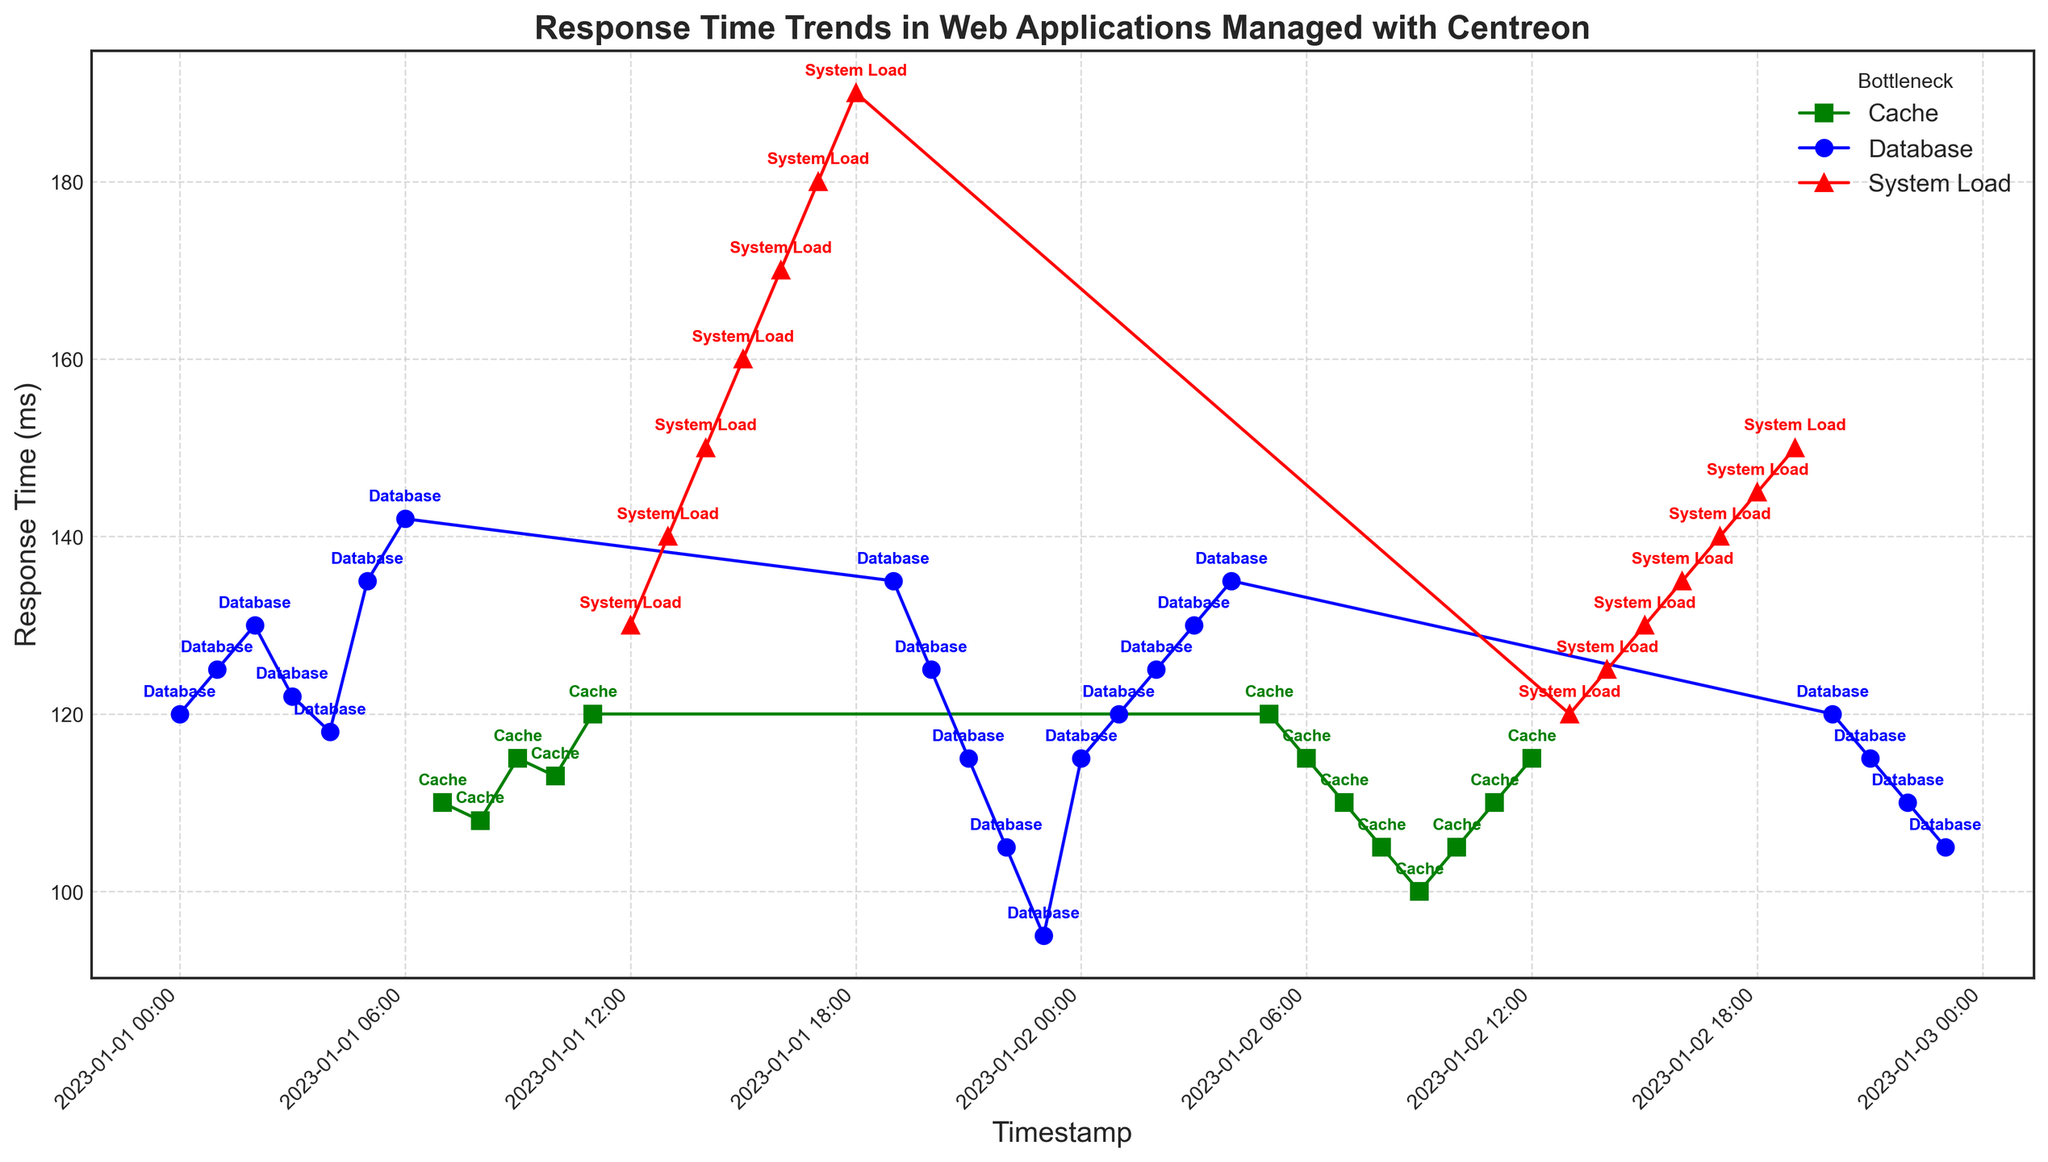What bottleneck shows the highest response time throughout the observed period? By inspecting the graph, the 'System Load' bottlenecks, represented in red, consistently show higher response times compared to 'Database' (blue) and 'Cache' (green) bottlenecks.
Answer: System Load What is the difference in response time between the highest recorded for 'System Load' and the lowest recorded for 'Database'? The highest response time for 'System Load' is 190 ms, while the lowest for 'Database' is 95 ms. The difference is 190 - 95 = 95 ms.
Answer: 95 ms How does the response time trend for 'Cache' bottlenecks compare in the morning (7:00 to 12:00) versus the afternoon (13:00 to 18:00)? In the morning, response times for 'Cache' are generally lower and stable, staying around 105-120 ms. In the afternoon, it switches to 'System Load' bottlenecks with response times starting from 120 ms and increasing continuously to 150 ms.
Answer: Lower and stable in the morning, increasing in the afternoon What is the mean response time for 'Database' bottlenecks over the entire period? The response times for 'Database' bottlenecks are 120, 125, 130, 122, 118, 135, 142, 135, 125, 115, 105, 95, 115, 120, 125, 130, and 135. Summing these values gives 1884. There are 17 data points, so the mean is 1884 / 17 ≈ 110.82 ms.
Answer: 110.82 ms Which bottleneck had the lowest response time on 2023-01-01 and what was the value? On inspecting the graph for the date 2023-01-01, the lowest response time is from a 'Database' bottleneck at 23:00, with a value of 95 ms.
Answer: Database, 95 ms Which time has the highest response time and which bottleneck was responsible for it? According to the graph, the highest response time recorded is at 2023-01-01T18:00:00Z with a response time of 190 ms, which is due to 'System Load'.
Answer: 18:00, System Load How many different bottlenecks are annotated in the figure? The annotations in the figure show three different bottlenecks: 'Database', 'Cache', and 'System Load'.
Answer: Three What is the trend for response time during the transition from 'Cache' to 'System Load' bottlenecks? As we move from 'Cache' to 'System Load' annotations, there is a noticeable increase in response time, starting from around 120 ms at the end of 'Cache' and continuously climbing to 190 ms for 'System Load'.
Answer: Increasing trend 